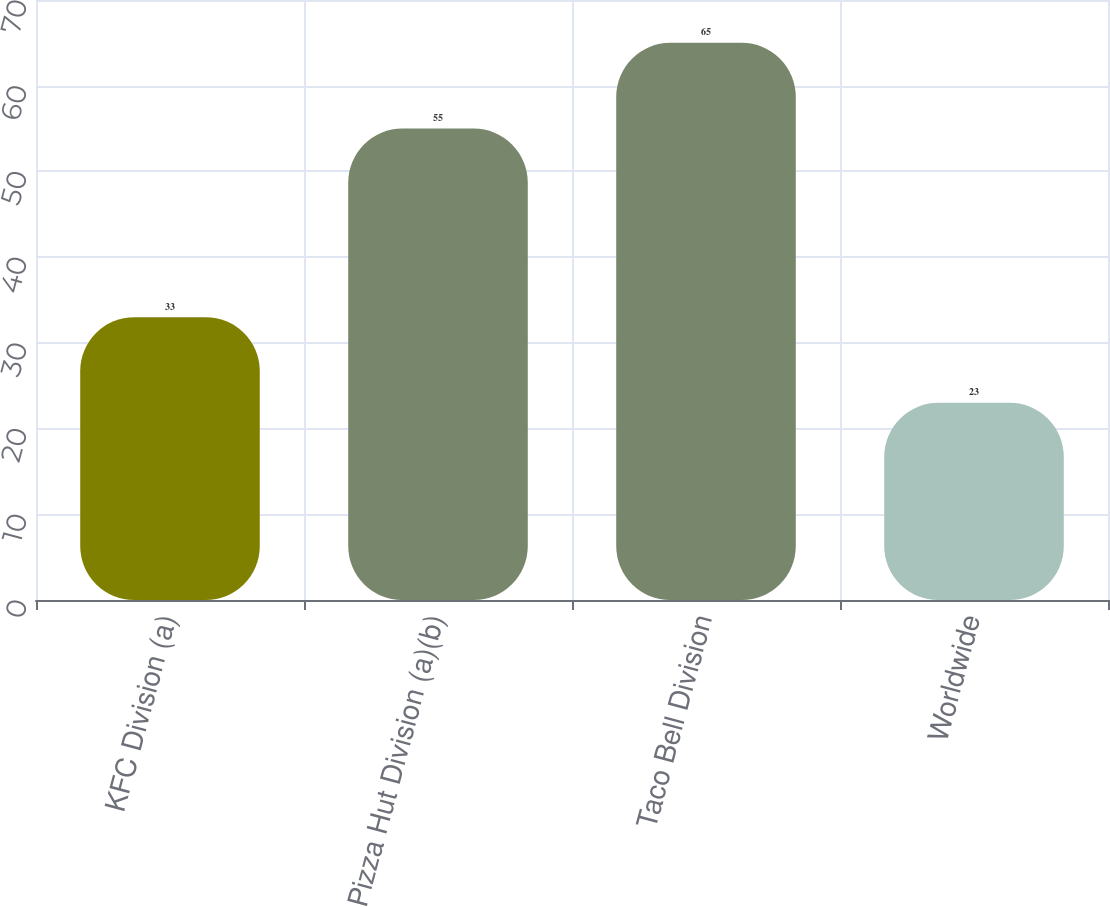Convert chart. <chart><loc_0><loc_0><loc_500><loc_500><bar_chart><fcel>KFC Division (a)<fcel>Pizza Hut Division (a)(b)<fcel>Taco Bell Division<fcel>Worldwide<nl><fcel>33<fcel>55<fcel>65<fcel>23<nl></chart> 